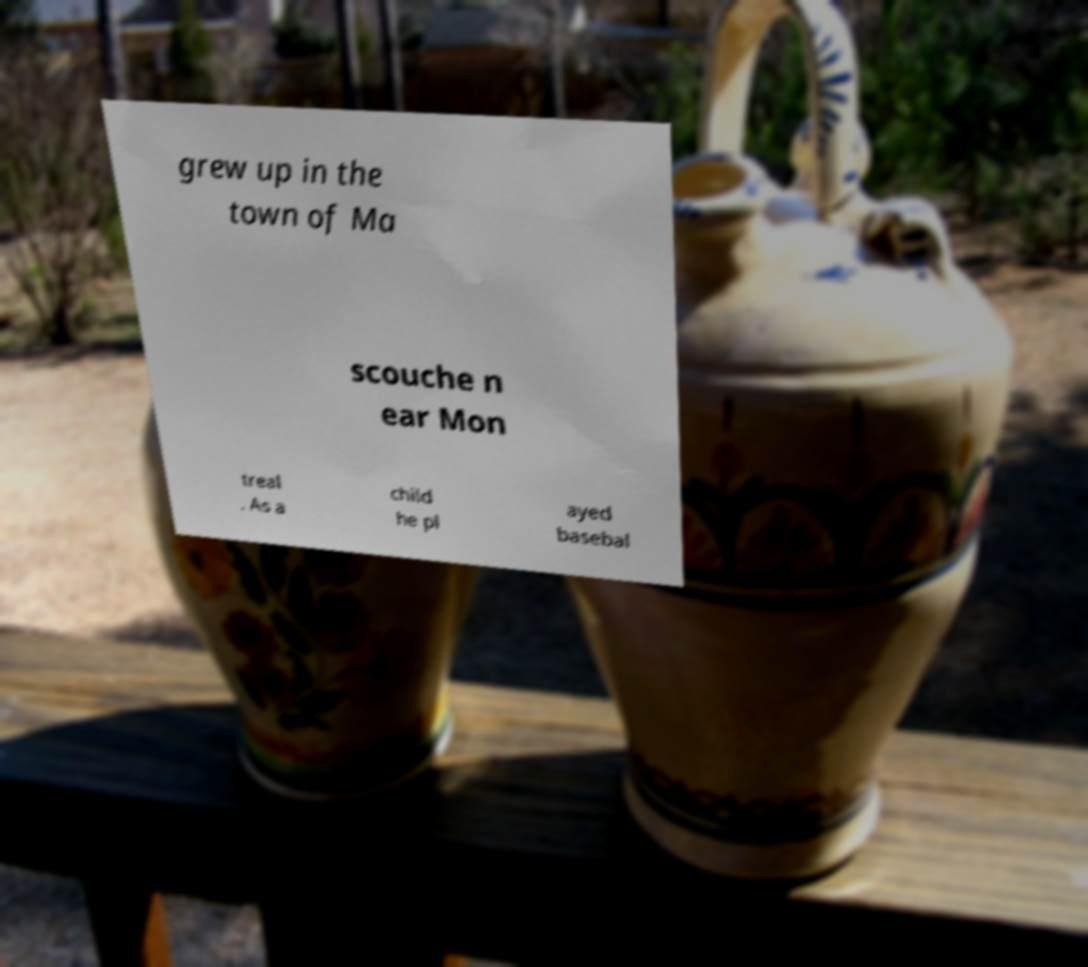Please read and relay the text visible in this image. What does it say? grew up in the town of Ma scouche n ear Mon treal . As a child he pl ayed basebal 